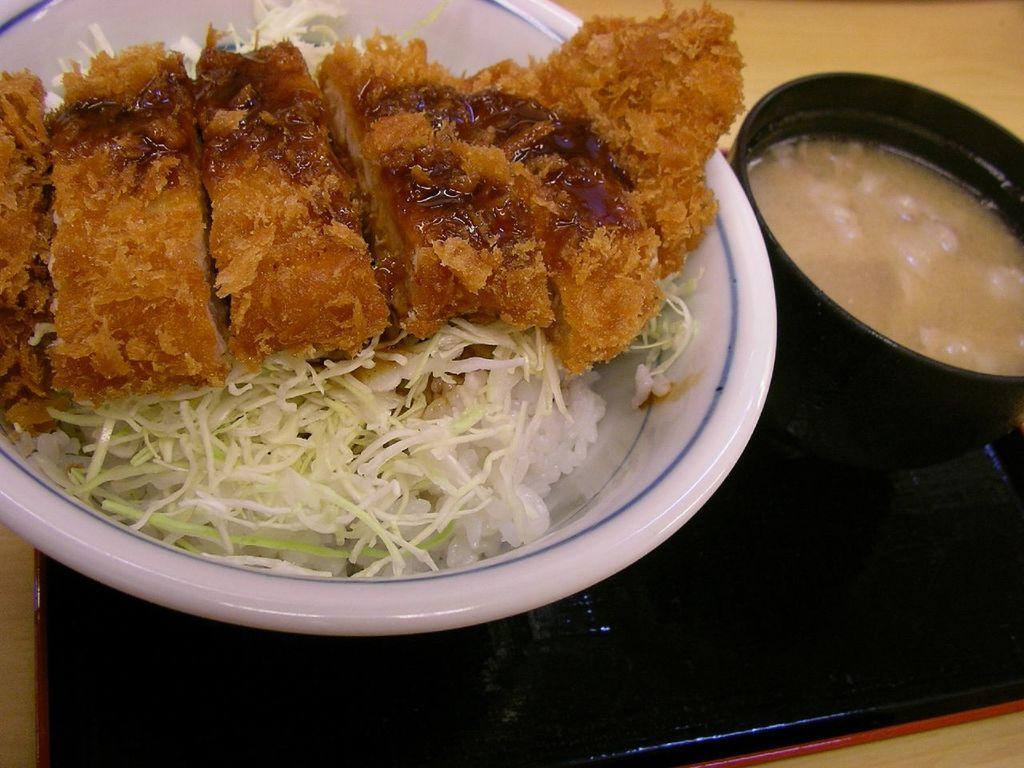What type of food is in the bowl in the image? The facts do not specify the type of food in the bowl. Where is the soup bowl located in the image? The soup bowl is on the right side of the image. What is present at the bottom of the image? There is an object at the bottom of the image. How many feet can be seen in the image? There are no feet visible in the image. What type of thing is the object at the bottom of the image? The facts do not specify the type of object at the bottom of the image. 